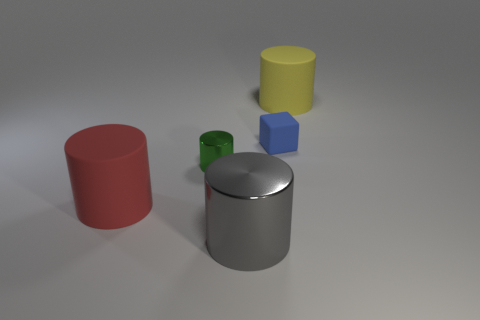Subtract all green metal cylinders. How many cylinders are left? 3 Add 3 small matte balls. How many objects exist? 8 Subtract all red cylinders. How many cylinders are left? 3 Subtract 2 cylinders. How many cylinders are left? 2 Subtract all cylinders. How many objects are left? 1 Subtract 0 purple balls. How many objects are left? 5 Subtract all cyan blocks. Subtract all cyan spheres. How many blocks are left? 1 Subtract all yellow cylinders. Subtract all matte things. How many objects are left? 1 Add 4 green objects. How many green objects are left? 5 Add 1 small green shiny objects. How many small green shiny objects exist? 2 